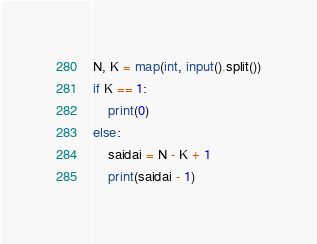<code> <loc_0><loc_0><loc_500><loc_500><_Python_>N, K = map(int, input().split())
if K == 1:
    print(0)
else:
    saidai = N - K + 1
    print(saidai - 1)
</code> 